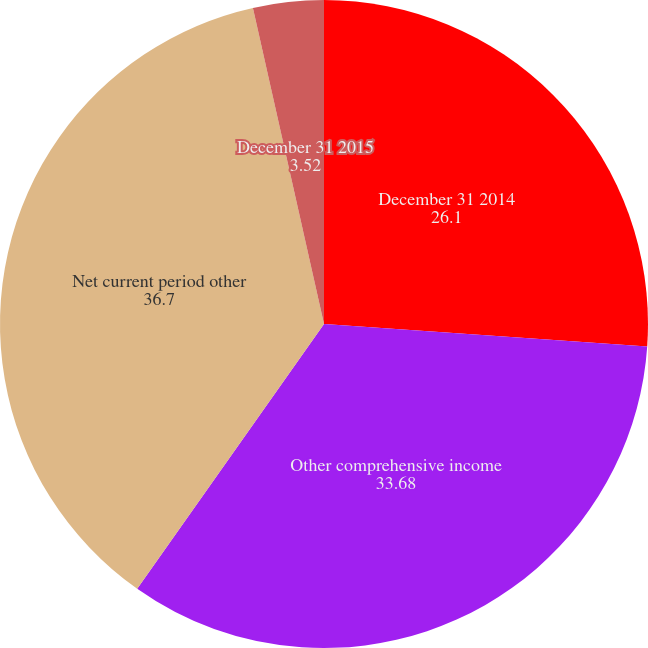Convert chart. <chart><loc_0><loc_0><loc_500><loc_500><pie_chart><fcel>December 31 2014<fcel>Other comprehensive income<fcel>Net current period other<fcel>December 31 2015<nl><fcel>26.1%<fcel>33.68%<fcel>36.7%<fcel>3.52%<nl></chart> 